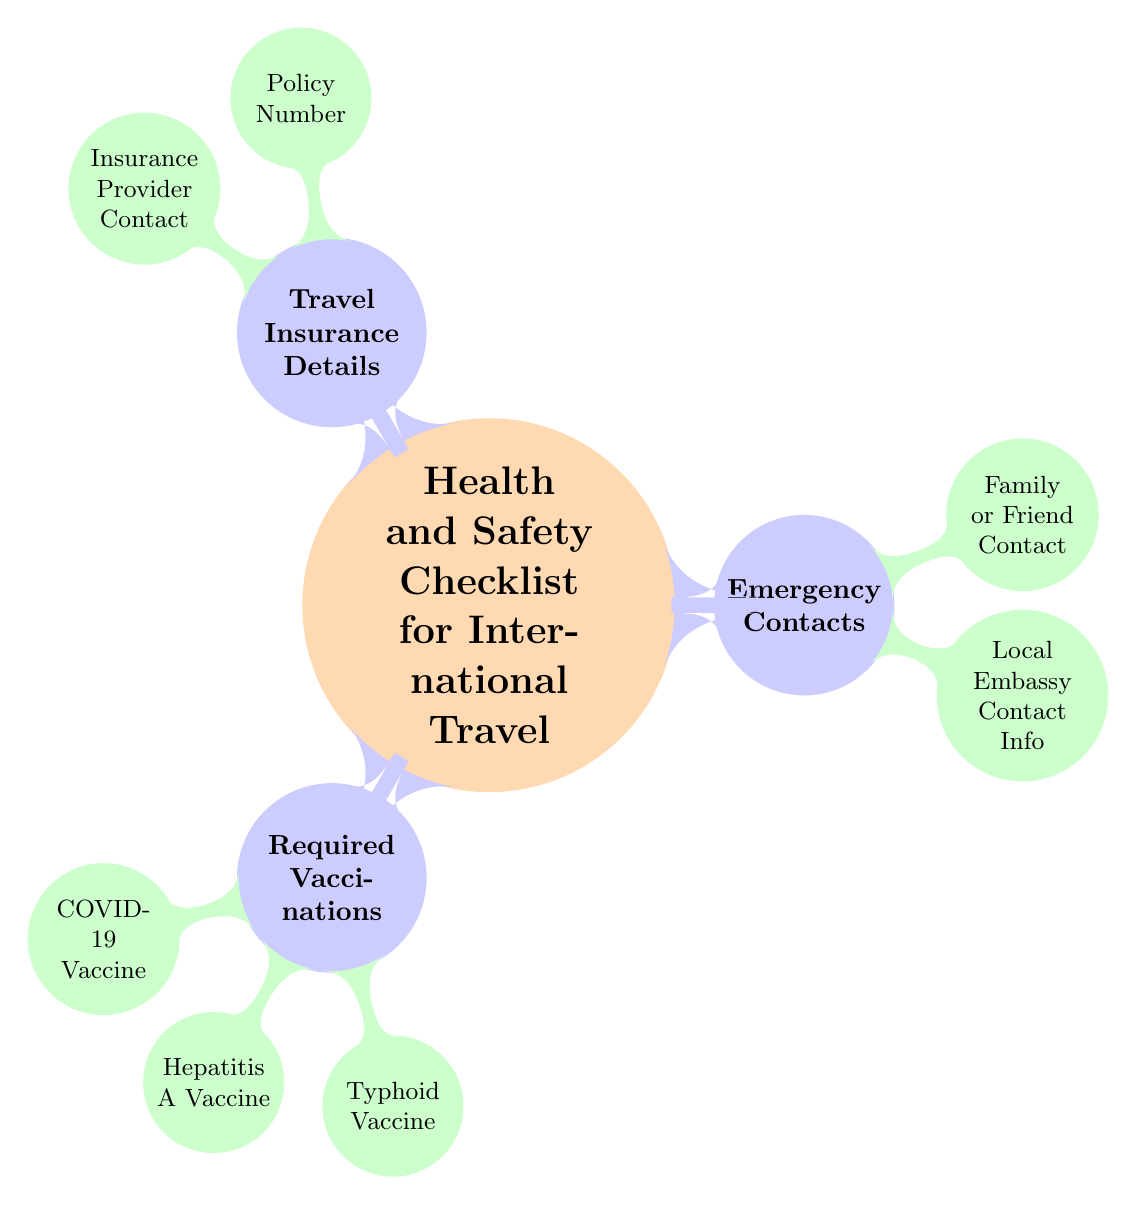What are the three categories in the checklist? The diagram consists of three main categories branching from the central node: Required Vaccinations, Emergency Contacts, and Travel Insurance Details. These categories are distinctly outlined under the main topic.
Answer: Required Vaccinations, Emergency Contacts, Travel Insurance Details How many specific vaccinations are listed under the Required Vaccinations category? Under the Required Vaccinations category, there are three specific vaccines mentioned: COVID-19 Vaccine, Hepatitis A Vaccine, and Typhoid Vaccine. This is determined by counting the number of child nodes connected to the Required Vaccinations node.
Answer: 3 What is included in the Emergency Contacts section? The Emergency Contacts section has two items listed: Local Embassy Contact Info and Family or Friend Contact. Each is a child node directly connected to Emergency Contacts.
Answer: Local Embassy Contact Info, Family or Friend Contact What is the first item listed under Travel Insurance Details? The first item listed under Travel Insurance Details is Policy Number. This can be identified as it is the first child node branching from the Travel Insurance Details parent node.
Answer: Policy Number Which category contains the information about vaccines? The category that contains information about vaccines is Required Vaccinations. This can be noted as Required Vaccinations is the first child category under the central node of the diagram.
Answer: Required Vaccinations What must you check for under Travel Insurance Details? Under Travel Insurance Details, you must check for two specific items: Policy Number and Insurance Provider Contact. This directly relates to the items listed under this category in the diagram.
Answer: Policy Number, Insurance Provider Contact What is the relationship between the Local Embassy Contact Info and the Emergency Contacts category? Local Embassy Contact Info is a child node under the Emergency Contacts category. This indicates that it is one of the crucial pieces of information associated with emergency contacts for travel safety.
Answer: Child node How does the structure of the diagram show the prioritization of travel safety elements? The structure of the diagram organizes three critical aspects of travel safety into distinct categories emanating from a central topic, allowing for easy identification of required areas of focus, starting from vaccinations to emergency contacts and then travel insurance. This hierarchical representation emphasizes the importance of each category collectively contributing to overall traveler safety.
Answer: Hierarchical representation 